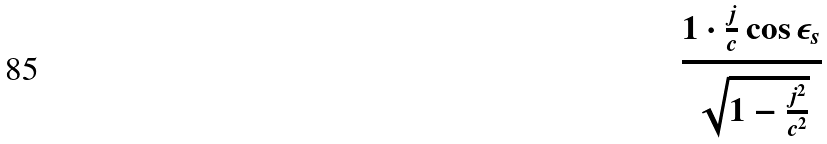Convert formula to latex. <formula><loc_0><loc_0><loc_500><loc_500>\frac { 1 \cdot \frac { j } { c } \cos \epsilon _ { s } } { \sqrt { 1 - \frac { j ^ { 2 } } { c ^ { 2 } } } }</formula> 